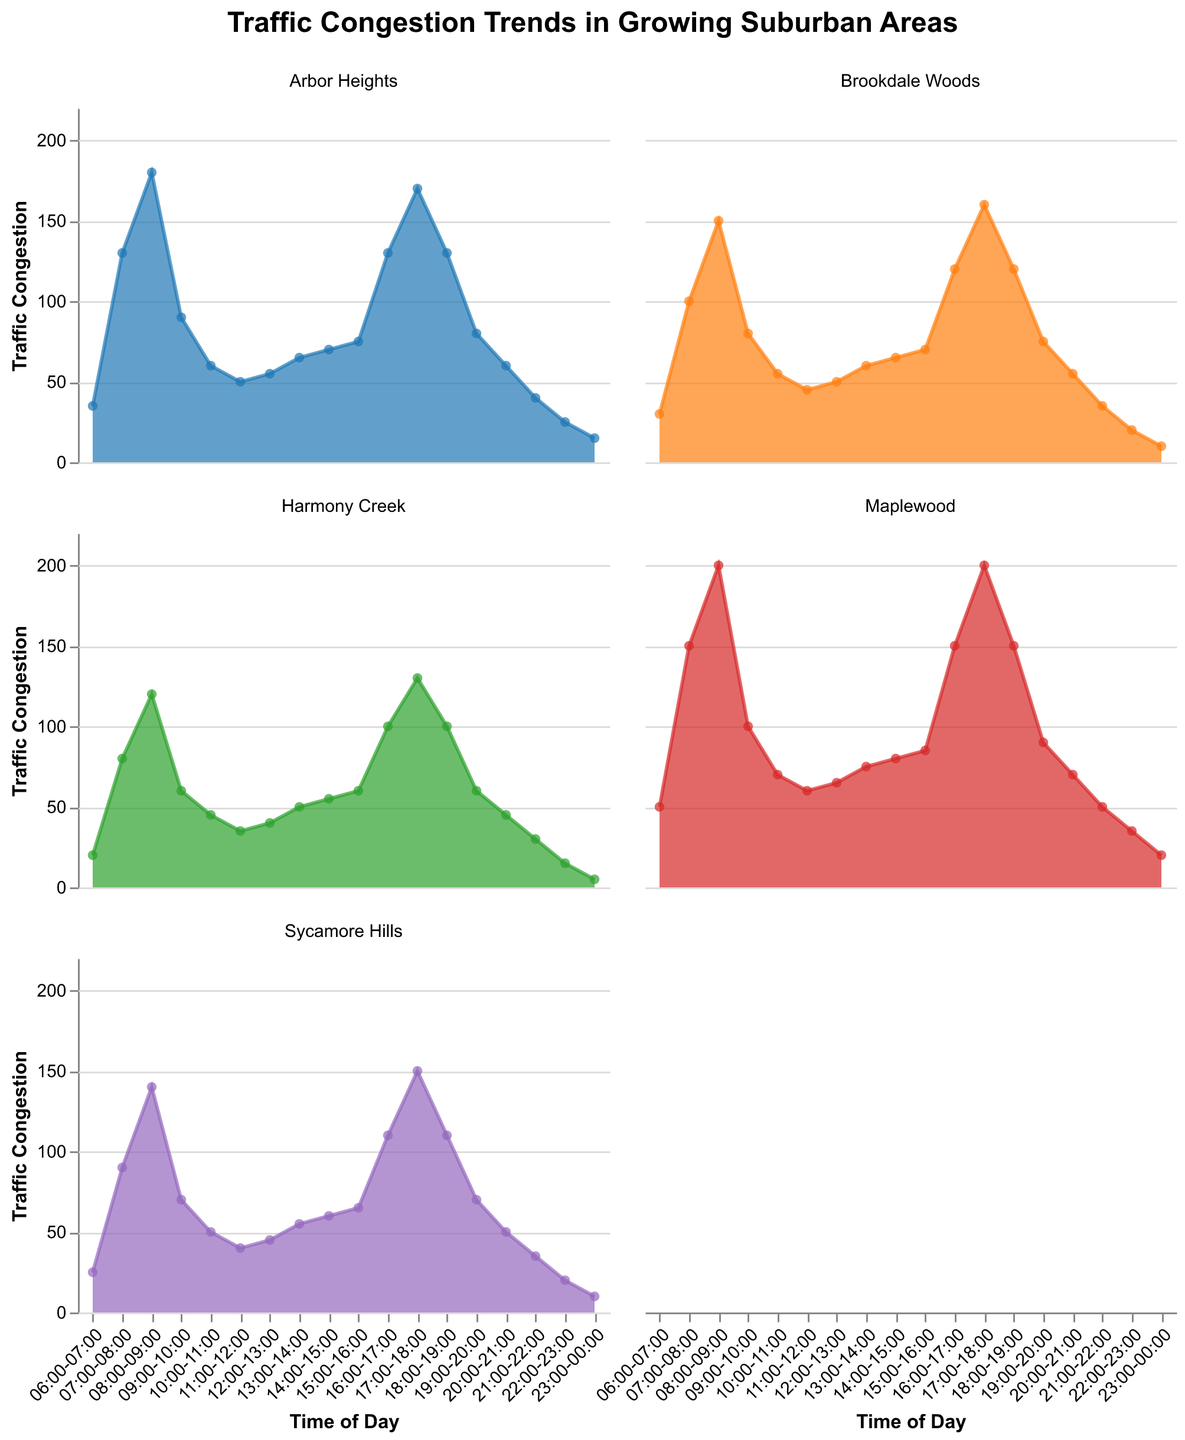What is the title of the figure? The title of the figure is located at the top center and it provides an overview of what the figure is about. In this case, it states the main theme.
Answer: Traffic Congestion Trends in Growing Suburban Areas At what time does Maplewood experience its highest traffic congestion? By examining the area chart for Maplewood, we observe the peak point, which occurs between 08:00-09:00 with a value of 200.
Answer: 08:00-09:00 Which suburban area has the least traffic congestion at 17:00-18:00? Looking at the data points for 17:00-18:00 for all areas, Harmony Creek has the smallest value with a congestion level of 130.
Answer: Harmony Creek What is the overall trend of traffic congestion in Maplewood from 06:00-12:00? Maplewood's congestion increases significantly from 06:00 to 09:00, peaking at 200, then drops to a lower, stable trend by 12:00.
Answer: Peaks and then decreases What is the combined traffic congestion for Arbor Heights and Sycamore Hills at 08:00-09:00? Adding the congestion values for Arbor Heights (180) and Sycamore Hills (140) at 08:00-09:00, we get a total of 320.
Answer: 320 When comparing Maplewood and Brookdale Woods, which area has a higher traffic congestion at 15:00-16:00? Maplewood has a congestion level of 85, while Brookdale Woods is at 70, making Maplewood the area with higher traffic congestion.
Answer: Maplewood What is the difference in traffic congestion between the peak times of Maplewood and Harmony Creek? Maplewood peaks at 08:00-09:00 with 200, Harmony Creek also peaks at the same time with 120, so the difference is 200 - 120.
Answer: 80 How does the traffic congestion in Arbor Heights during the evening (18:00-00:00) compare to that in the morning (06:00-12:00)? Calculating averages, morning (35+130+180+90+60+50)/6 = 90.83, evening (130+80+60+40+25+15)/6 = 58.33, so morning congestion is higher.
Answer: Higher in the morning Which area has the most stable (least variable) traffic congestion throughout the day? By visually analyzing the charts, Harmony Creek shows the least variability with smaller fluctuations throughout.
Answer: Harmony Creek 